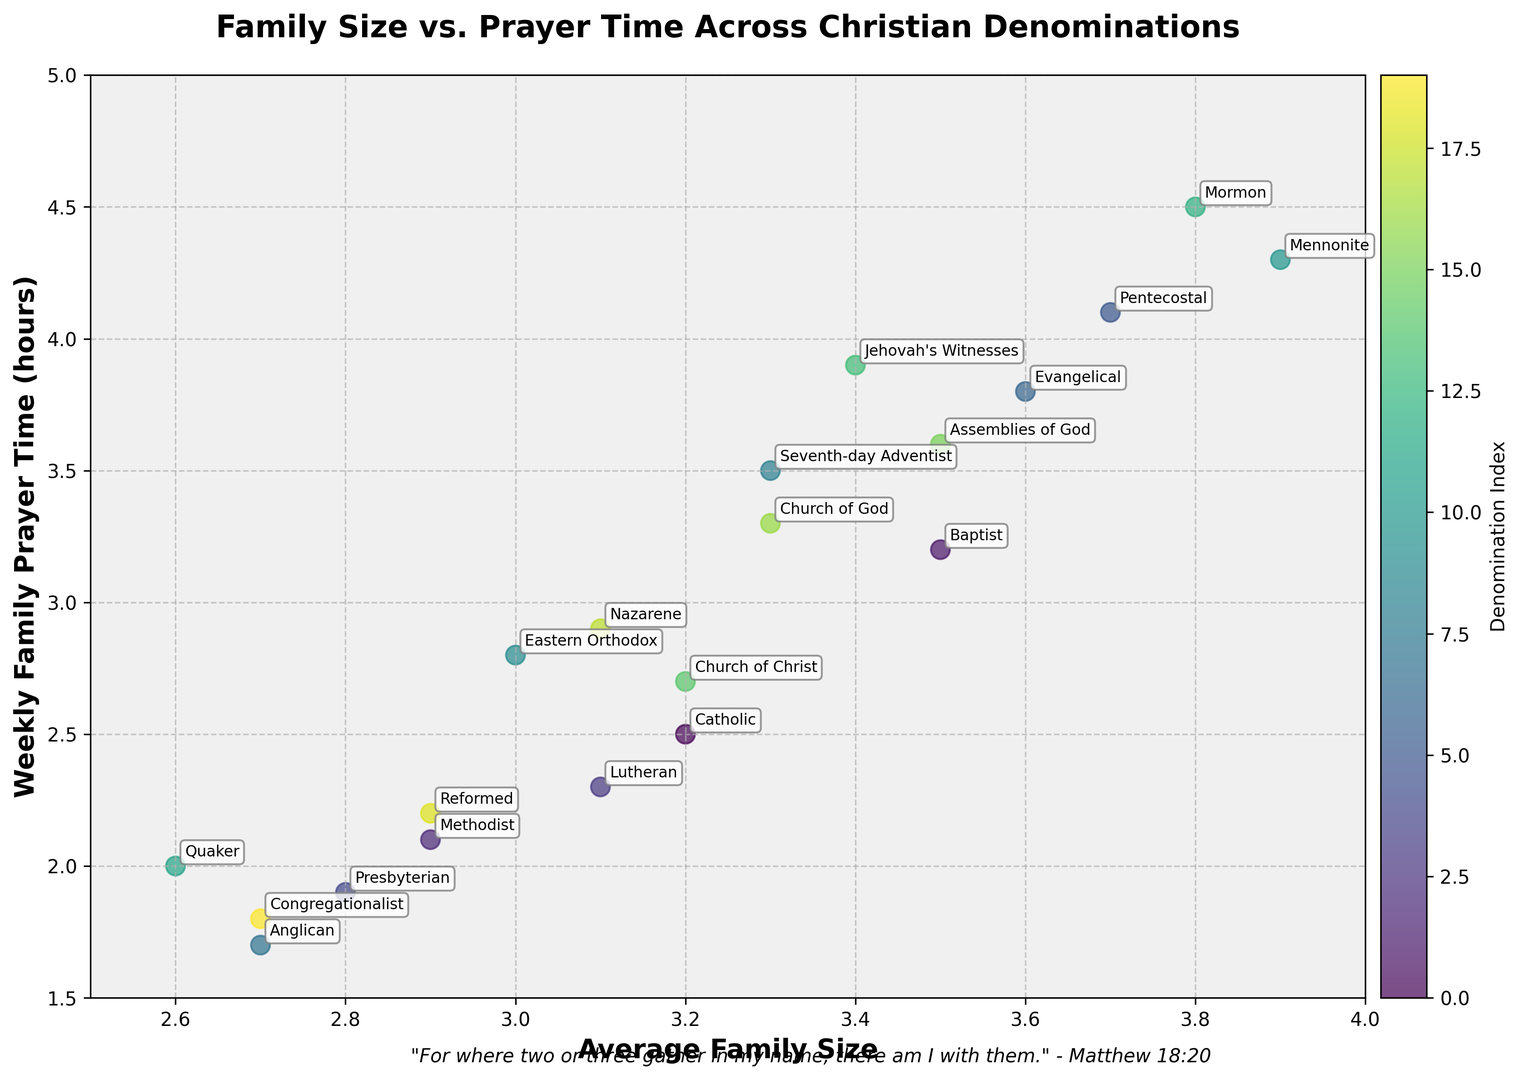What denomination has the smallest average family size? The scatter plot shows the family sizes where the denomination name is annotated. By looking for the smallest value on the x-axis, you can see that the lowest average family size is 2.6. The corresponding label is "Quaker".
Answer: Quaker Which denomination dedicates the most time to weekly family prayer? The scatter plot marks weekly prayer times on the y-axis, and the highest point there is 4.5 hours. The corresponding denomination label is "Mormon".
Answer: Mormon Do Pentecostals or Evangelicals spend more time in weekly family prayer? By comparing the y-coordinate positions of these two denominations' labels on the y-axis, Pentecostals are at 4.1 hours, while Evangelicals are at 3.8 hours.
Answer: Pentecostals What is the average weekly family prayer time for denominations with an average family size of at least 3.5? Identifying denominations with family sizes of 3.5 or greater (Baptist, Pentecostal, Evangelical, Mennonite, and Mormon), their weekly prayer times are 3.2, 4.1, 3.8, 4.3, and 4.5 respectively. Summing these values (3.2+4.1+3.8+4.3+4.5=19.9) and dividing by 5 yields an average of 3.98 hours.
Answer: 3.98 hours Which denomination has an average family size closest to the mean average family size of all denominations? First, calculate the mean average family size: sum all the given averages (3.2+3.5+2.9+3.1+2.8+3.7+3.6+2.7+3.3+3.0+3.9+2.6+3.8+3.4+3.2+3.5+3.3+3.1+2.9+2.7 = 63.2) and divide by the number of denominations (20), yielding 3.16. The closest values to 3.16 are Catholic and Church of Christ, both at 3.2.
Answer: Catholic, Church of Christ What visual trend can be observed in relation to average family size and weekly family prayer time? By observing the general direction of the plotted points on the scatter plot, it appears that families with larger average sizes tend to spend more time in weekly prayer. The points generally slope upwards from left to right.
Answer: Larger families pray more Which denomination out of Jehovah's Witnesses and Seventh-day Adventist spends more time in prayer weekly? To compare, look at the y-axis positions for both labels: Jehovah's Witnesses are at 3.9 hours and Seventh-day Adventist at 3.5 hours.
Answer: Jehovah's Witnesses What is the difference in weekly prayer time between the denomination with the highest prayer hours and the denomination with the lowest? The highest value on the y-axis is 4.5 hours (Mormon) and the lowest is 1.7 hours (Anglican). The difference is calculated as 4.5 - 1.7 = 2.8.
Answer: 2.8 hours 